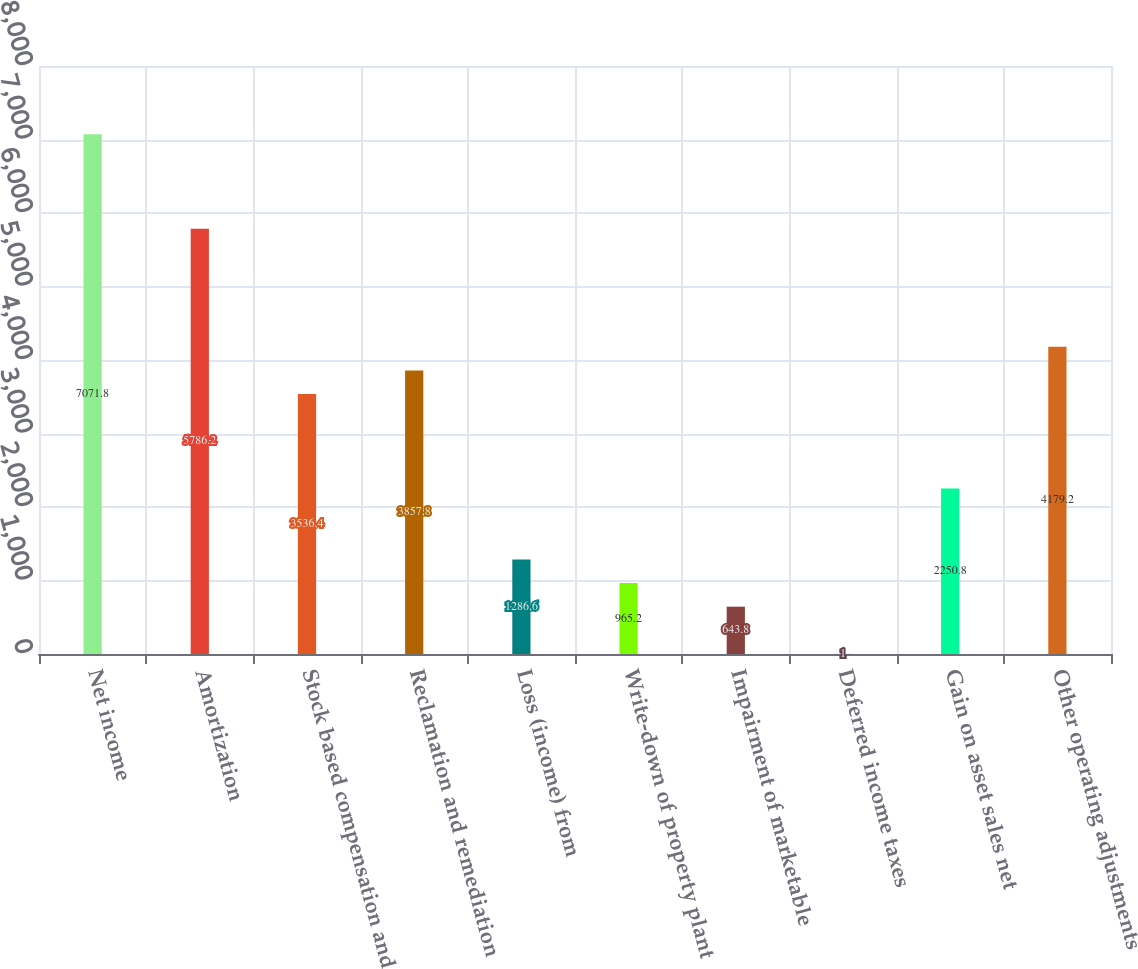Convert chart to OTSL. <chart><loc_0><loc_0><loc_500><loc_500><bar_chart><fcel>Net income<fcel>Amortization<fcel>Stock based compensation and<fcel>Reclamation and remediation<fcel>Loss (income) from<fcel>Write-down of property plant<fcel>Impairment of marketable<fcel>Deferred income taxes<fcel>Gain on asset sales net<fcel>Other operating adjustments<nl><fcel>7071.8<fcel>5786.2<fcel>3536.4<fcel>3857.8<fcel>1286.6<fcel>965.2<fcel>643.8<fcel>1<fcel>2250.8<fcel>4179.2<nl></chart> 